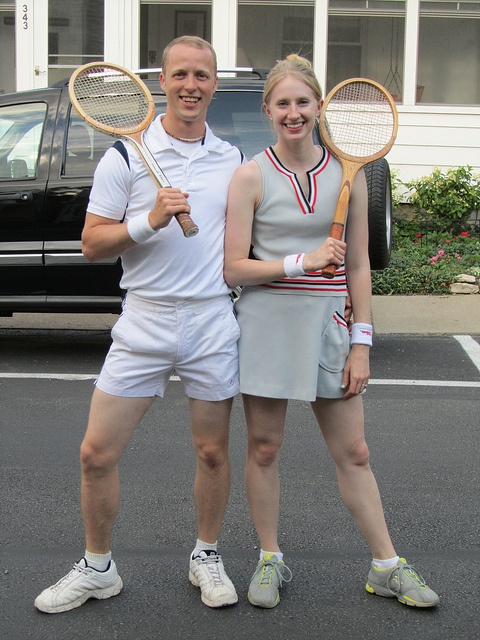Describe the objects in this image and their specific colors. I can see people in gray, lavender, and darkgray tones, people in gray, darkgray, and tan tones, truck in gray, black, darkgray, and lightgray tones, tennis racket in gray, lightgray, tan, and darkgray tones, and tennis racket in gray, darkgray, tan, and lightgray tones in this image. 